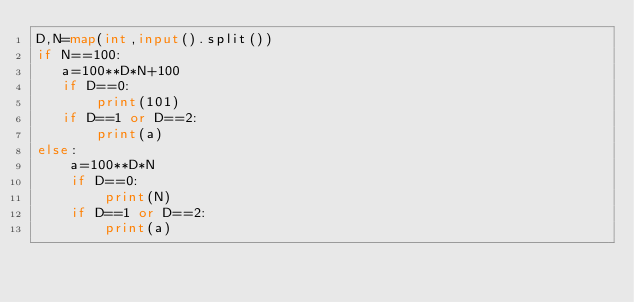<code> <loc_0><loc_0><loc_500><loc_500><_Python_>D,N=map(int,input().split())
if N==100:
   a=100**D*N+100
   if D==0:
       print(101)
   if D==1 or D==2:
       print(a)     
else:
    a=100**D*N
    if D==0:
        print(N)
    if D==1 or D==2:
        print(a)</code> 